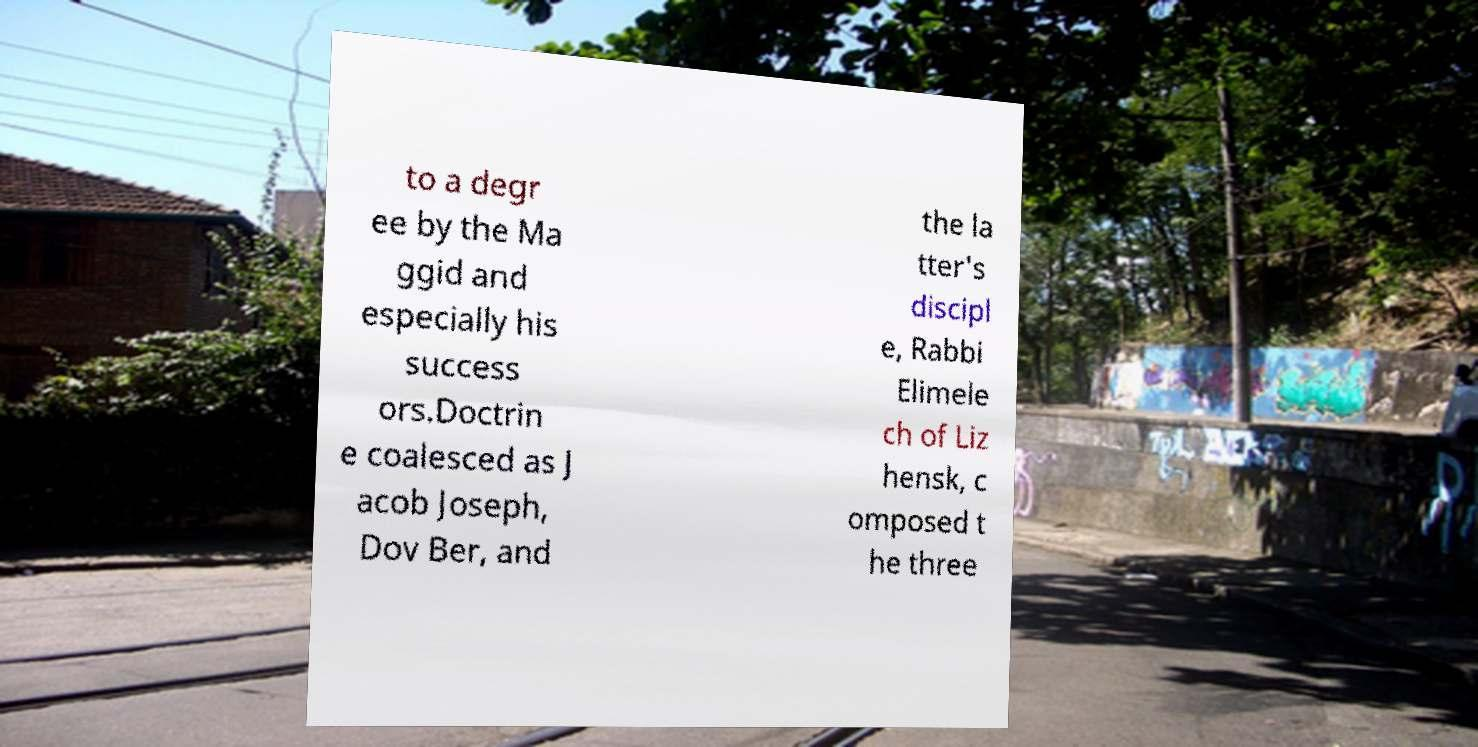Could you extract and type out the text from this image? to a degr ee by the Ma ggid and especially his success ors.Doctrin e coalesced as J acob Joseph, Dov Ber, and the la tter's discipl e, Rabbi Elimele ch of Liz hensk, c omposed t he three 